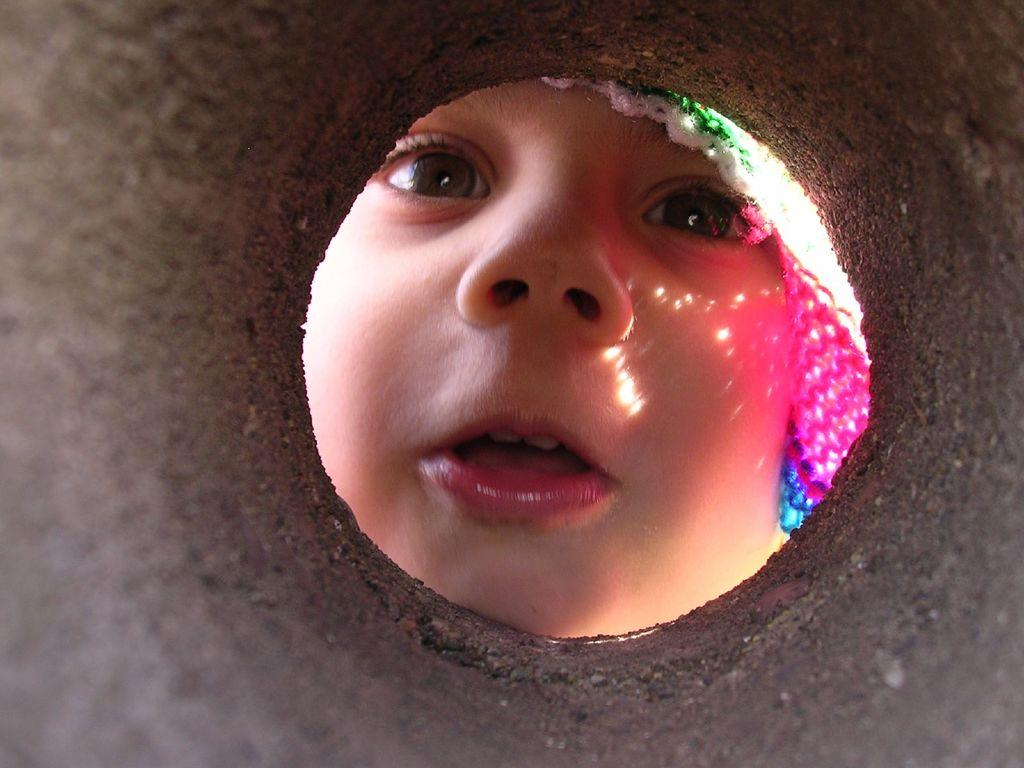What is the main subject of the image? The main subject of the image is a kid. How is the kid visible in the image? The kid is visible through a hole. What type of surprise can be seen in the image? There is no surprise visible in the image; it features a kid visible through a hole. What kind of story can be read from the image? There is no story depicted in the image; it only shows a kid visible through a hole. 